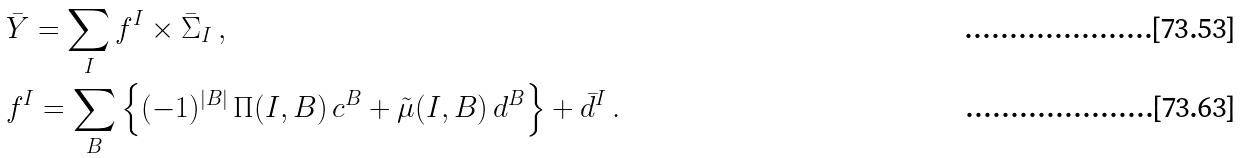<formula> <loc_0><loc_0><loc_500><loc_500>& \bar { Y } = \sum _ { I } f ^ { I } \times \bar { \Sigma } _ { I } \, , \\ & f ^ { I } = \sum _ { B } \left \{ ( - 1 ) ^ { | B | } \, \Pi ( I , B ) \, c ^ { B } + \tilde { \mu } ( I , B ) \, d ^ { B } \right \} + \bar { d } ^ { I } \, .</formula> 